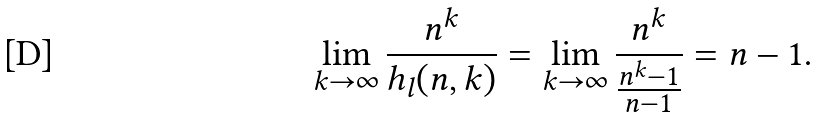Convert formula to latex. <formula><loc_0><loc_0><loc_500><loc_500>\lim _ { k \to \infty } \frac { n ^ { k } } { h _ { l } ( n , k ) } = \lim _ { k \to \infty } \frac { n ^ { k } } { \frac { n ^ { k } - 1 } { n - 1 } } = n - 1 .</formula> 